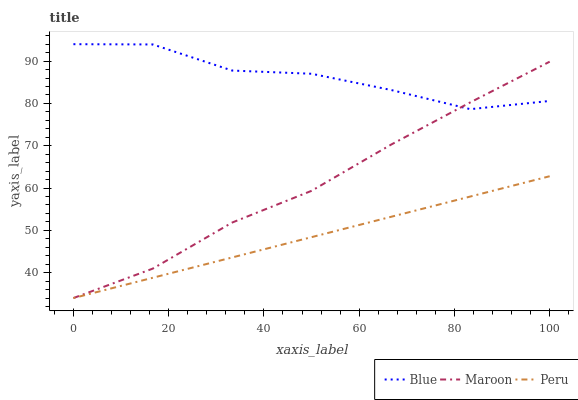Does Peru have the minimum area under the curve?
Answer yes or no. Yes. Does Blue have the maximum area under the curve?
Answer yes or no. Yes. Does Maroon have the minimum area under the curve?
Answer yes or no. No. Does Maroon have the maximum area under the curve?
Answer yes or no. No. Is Peru the smoothest?
Answer yes or no. Yes. Is Blue the roughest?
Answer yes or no. Yes. Is Maroon the smoothest?
Answer yes or no. No. Is Maroon the roughest?
Answer yes or no. No. Does Peru have the lowest value?
Answer yes or no. Yes. Does Blue have the highest value?
Answer yes or no. Yes. Does Maroon have the highest value?
Answer yes or no. No. Is Peru less than Blue?
Answer yes or no. Yes. Is Blue greater than Peru?
Answer yes or no. Yes. Does Maroon intersect Peru?
Answer yes or no. Yes. Is Maroon less than Peru?
Answer yes or no. No. Is Maroon greater than Peru?
Answer yes or no. No. Does Peru intersect Blue?
Answer yes or no. No. 